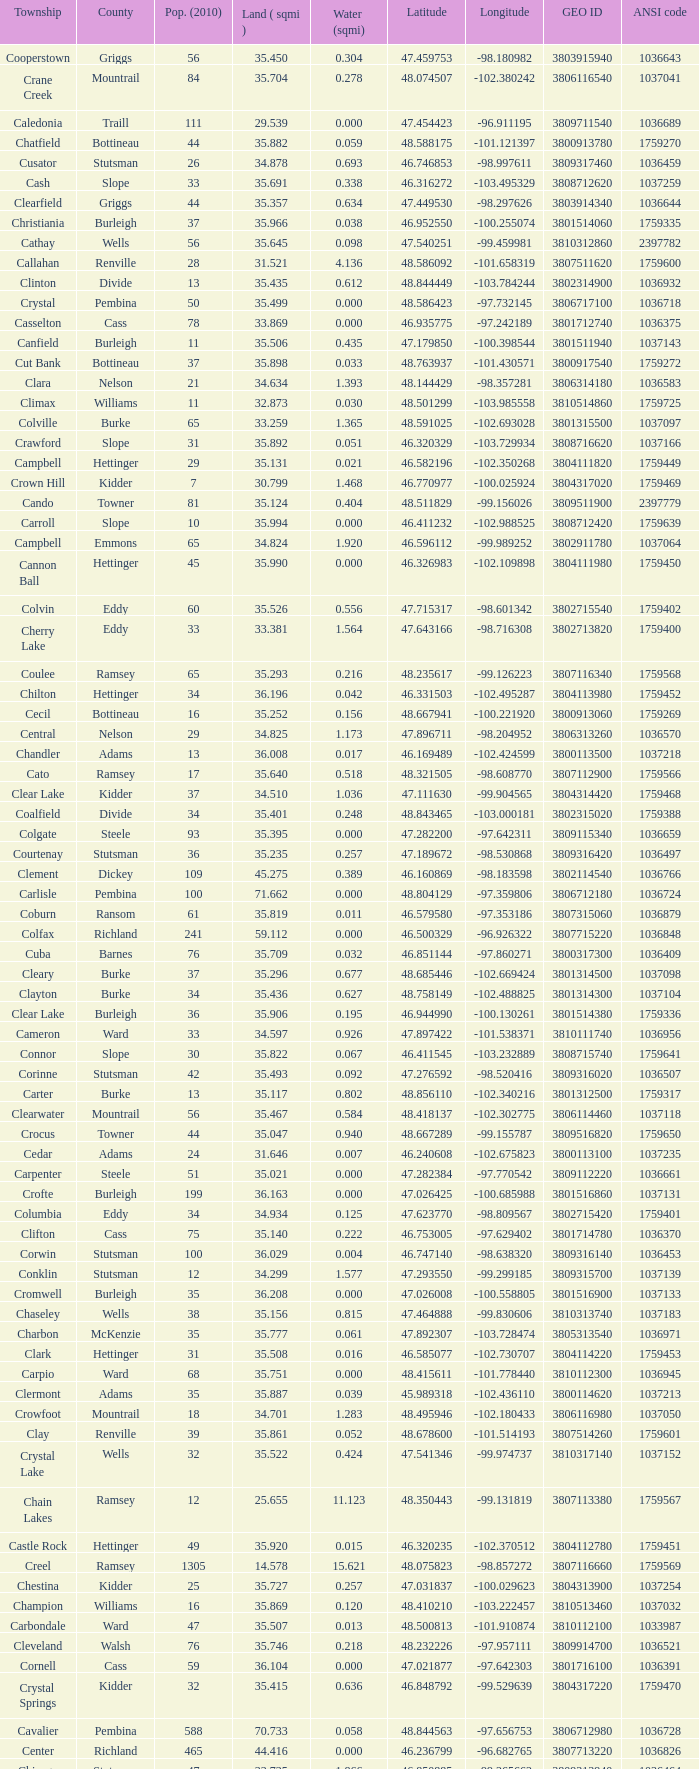What was the latitude of the Clearwater townsship? 48.418137. 